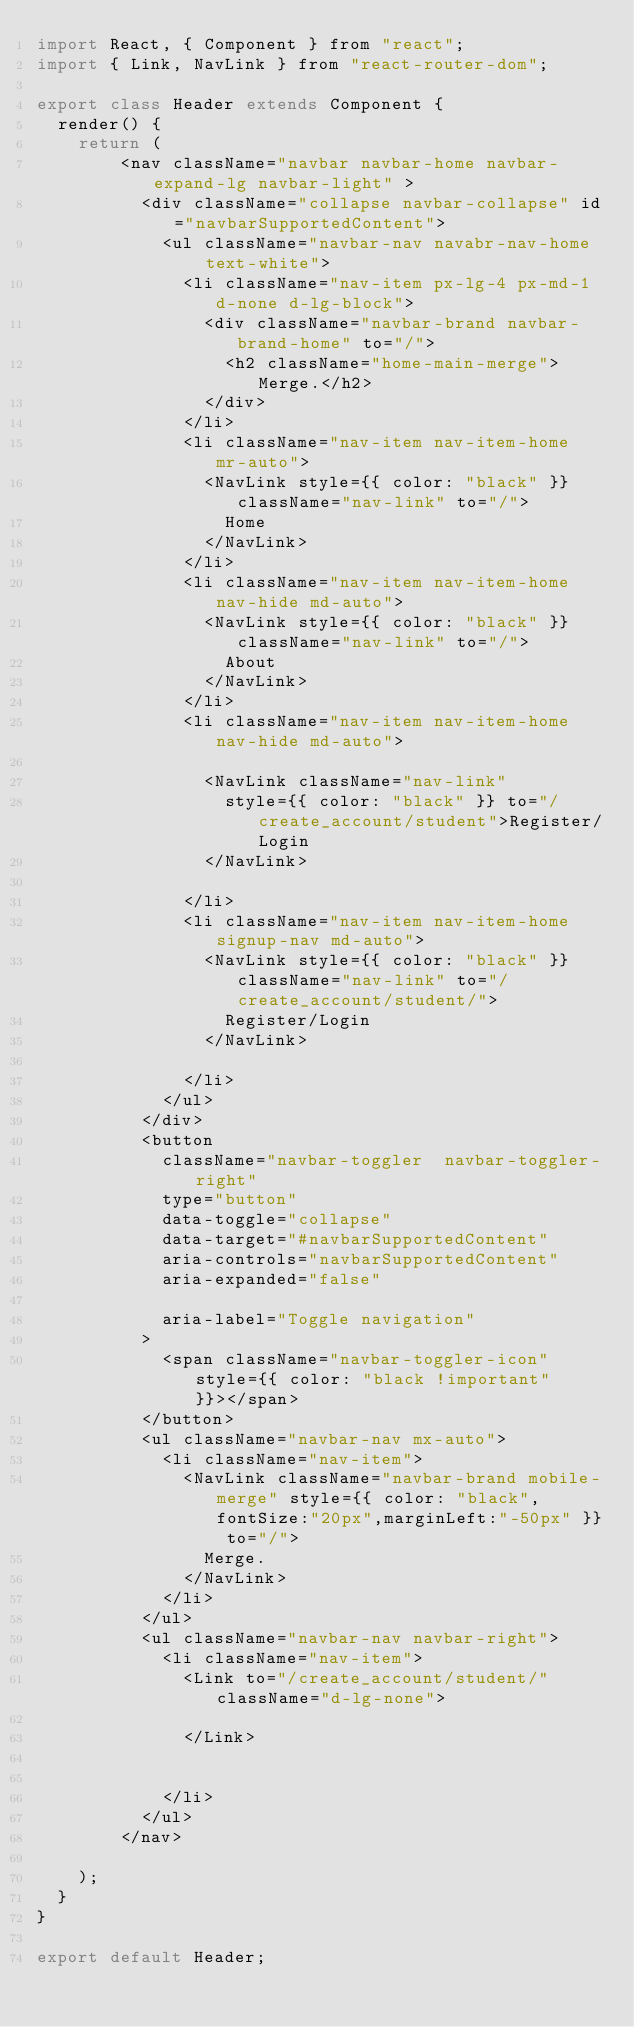Convert code to text. <code><loc_0><loc_0><loc_500><loc_500><_JavaScript_>import React, { Component } from "react";
import { Link, NavLink } from "react-router-dom";

export class Header extends Component {
  render() {
    return (
        <nav className="navbar navbar-home navbar-expand-lg navbar-light" >
          <div className="collapse navbar-collapse" id="navbarSupportedContent">
            <ul className="navbar-nav navabr-nav-home  text-white">
              <li className="nav-item px-lg-4 px-md-1 d-none d-lg-block">
                <div className="navbar-brand navbar-brand-home" to="/">
                  <h2 className="home-main-merge">Merge.</h2>
                </div>
              </li>
              <li className="nav-item nav-item-home  mr-auto">
                <NavLink style={{ color: "black" }} className="nav-link" to="/">
                  Home
                </NavLink>
              </li>
              <li className="nav-item nav-item-home  nav-hide md-auto">
                <NavLink style={{ color: "black" }} className="nav-link" to="/">
                  About
                </NavLink>
              </li>
              <li className="nav-item nav-item-home  nav-hide md-auto">

                <NavLink className="nav-link"
                  style={{ color: "black" }} to="/create_account/student">Register/Login
                </NavLink>

              </li>
              <li className="nav-item nav-item-home  signup-nav md-auto">
                <NavLink style={{ color: "black" }} className="nav-link" to="/create_account/student/">
                  Register/Login
                </NavLink>

              </li>
            </ul>
          </div>
          <button
            className="navbar-toggler  navbar-toggler-right"
            type="button"
            data-toggle="collapse"
            data-target="#navbarSupportedContent"
            aria-controls="navbarSupportedContent"
            aria-expanded="false"

            aria-label="Toggle navigation"
          >
            <span className="navbar-toggler-icon" style={{ color: "black !important" }}></span>
          </button>
          <ul className="navbar-nav mx-auto">
            <li className="nav-item">
              <NavLink className="navbar-brand mobile-merge" style={{ color: "black",fontSize:"20px",marginLeft:"-50px" }} to="/">
                Merge.
              </NavLink>
            </li>
          </ul>
          <ul className="navbar-nav navbar-right">
            <li className="nav-item">
              <Link to="/create_account/student/" className="d-lg-none">

              </Link>


            </li>
          </ul>
        </nav>
     
    );
  }
}

export default Header;
</code> 